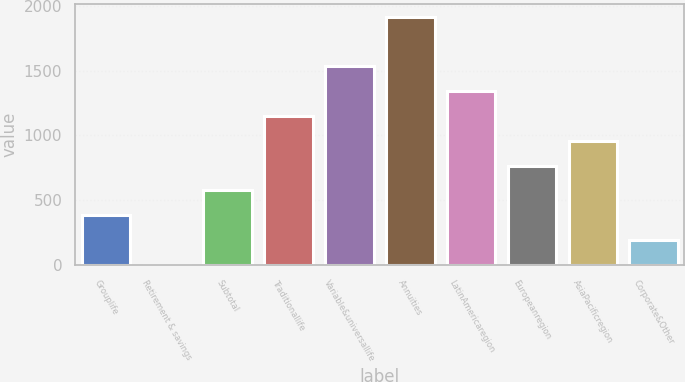Convert chart to OTSL. <chart><loc_0><loc_0><loc_500><loc_500><bar_chart><fcel>Grouplife<fcel>Retirement & savings<fcel>Subtotal<fcel>Traditionallife<fcel>Variable&universallife<fcel>Annuities<fcel>LatinAmericaregion<fcel>Europeanregion<fcel>AsiaPacificregion<fcel>Corporate&Other<nl><fcel>384.2<fcel>1<fcel>575.8<fcel>1150.6<fcel>1533.8<fcel>1917<fcel>1342.2<fcel>767.4<fcel>959<fcel>192.6<nl></chart> 